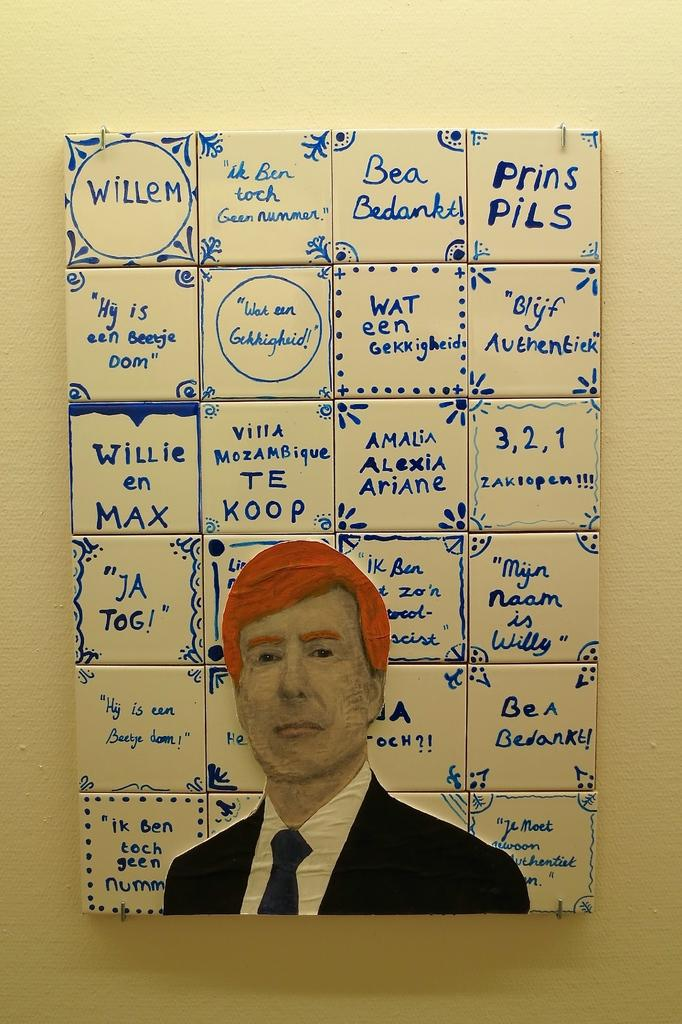What is depicted on the paper in the image? A person's picture is drawn on the paper in the image. What else can be seen in the image besides the paper? There are cubes with text written on them in the image. Can you describe the garden in the image? There is no garden present in the image; it only features a paper with a person's picture drawn on it and cubes with text written on them. 